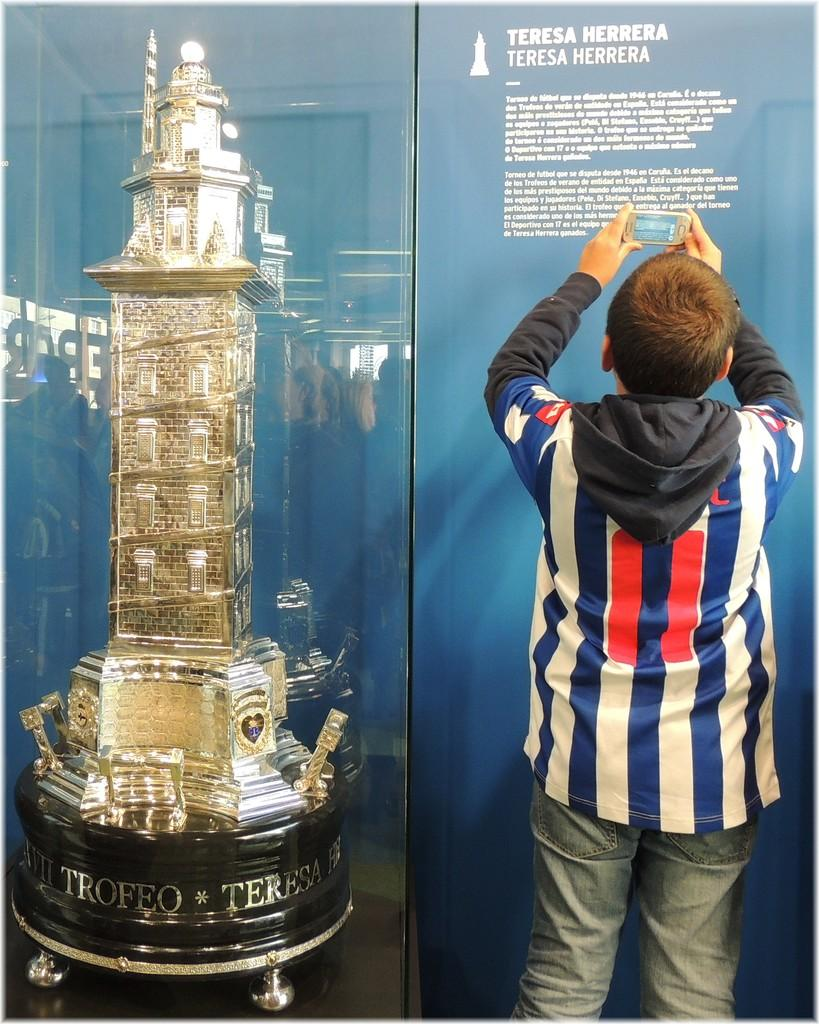<image>
Create a compact narrative representing the image presented. A boy is taking a picture of Theresa Herra memorial 